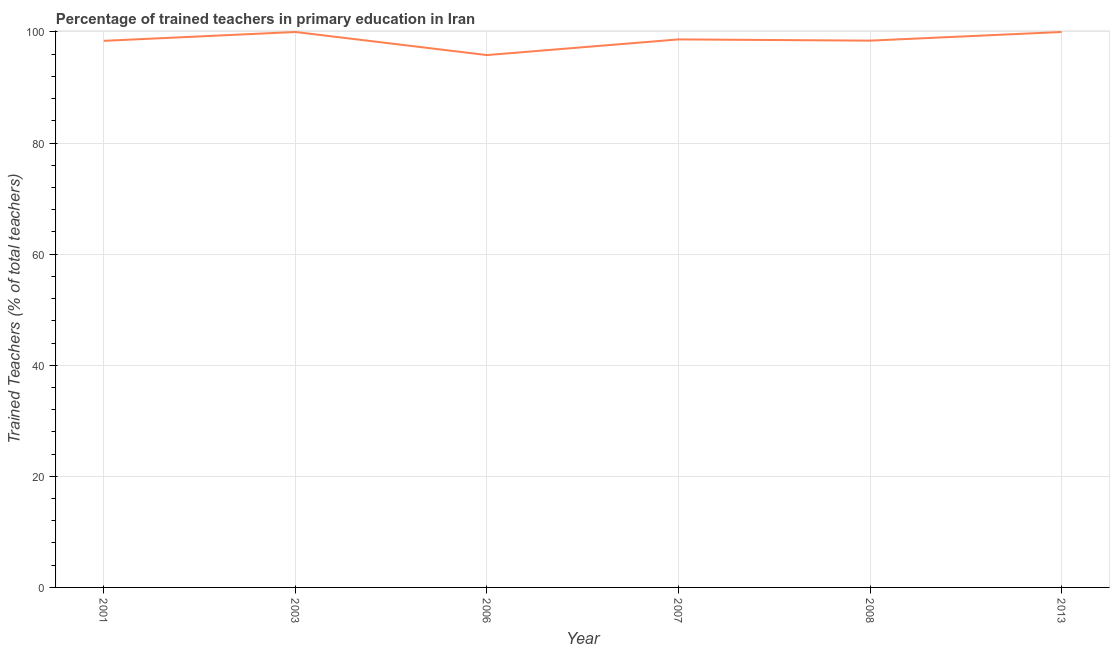What is the percentage of trained teachers in 2006?
Give a very brief answer. 95.84. Across all years, what is the maximum percentage of trained teachers?
Your response must be concise. 100. Across all years, what is the minimum percentage of trained teachers?
Your response must be concise. 95.84. In which year was the percentage of trained teachers maximum?
Offer a very short reply. 2003. What is the sum of the percentage of trained teachers?
Your answer should be compact. 591.35. What is the difference between the percentage of trained teachers in 2007 and 2013?
Make the answer very short. -1.34. What is the average percentage of trained teachers per year?
Ensure brevity in your answer.  98.56. What is the median percentage of trained teachers?
Keep it short and to the point. 98.55. Do a majority of the years between 2001 and 2006 (inclusive) have percentage of trained teachers greater than 48 %?
Give a very brief answer. Yes. What is the ratio of the percentage of trained teachers in 2006 to that in 2007?
Give a very brief answer. 0.97. Is the percentage of trained teachers in 2006 less than that in 2008?
Give a very brief answer. Yes. Is the sum of the percentage of trained teachers in 2001 and 2008 greater than the maximum percentage of trained teachers across all years?
Give a very brief answer. Yes. What is the difference between the highest and the lowest percentage of trained teachers?
Offer a terse response. 4.16. In how many years, is the percentage of trained teachers greater than the average percentage of trained teachers taken over all years?
Give a very brief answer. 3. What is the difference between two consecutive major ticks on the Y-axis?
Give a very brief answer. 20. Are the values on the major ticks of Y-axis written in scientific E-notation?
Offer a terse response. No. Does the graph contain any zero values?
Your answer should be compact. No. Does the graph contain grids?
Make the answer very short. Yes. What is the title of the graph?
Give a very brief answer. Percentage of trained teachers in primary education in Iran. What is the label or title of the Y-axis?
Make the answer very short. Trained Teachers (% of total teachers). What is the Trained Teachers (% of total teachers) of 2001?
Offer a terse response. 98.4. What is the Trained Teachers (% of total teachers) in 2003?
Make the answer very short. 100. What is the Trained Teachers (% of total teachers) in 2006?
Your answer should be compact. 95.84. What is the Trained Teachers (% of total teachers) in 2007?
Provide a short and direct response. 98.66. What is the Trained Teachers (% of total teachers) of 2008?
Provide a short and direct response. 98.44. What is the difference between the Trained Teachers (% of total teachers) in 2001 and 2003?
Your answer should be compact. -1.6. What is the difference between the Trained Teachers (% of total teachers) in 2001 and 2006?
Keep it short and to the point. 2.56. What is the difference between the Trained Teachers (% of total teachers) in 2001 and 2007?
Offer a terse response. -0.26. What is the difference between the Trained Teachers (% of total teachers) in 2001 and 2008?
Provide a short and direct response. -0.04. What is the difference between the Trained Teachers (% of total teachers) in 2001 and 2013?
Offer a terse response. -1.6. What is the difference between the Trained Teachers (% of total teachers) in 2003 and 2006?
Your answer should be very brief. 4.16. What is the difference between the Trained Teachers (% of total teachers) in 2003 and 2007?
Your answer should be compact. 1.34. What is the difference between the Trained Teachers (% of total teachers) in 2003 and 2008?
Make the answer very short. 1.56. What is the difference between the Trained Teachers (% of total teachers) in 2006 and 2007?
Offer a very short reply. -2.82. What is the difference between the Trained Teachers (% of total teachers) in 2006 and 2008?
Your answer should be very brief. -2.6. What is the difference between the Trained Teachers (% of total teachers) in 2006 and 2013?
Your response must be concise. -4.16. What is the difference between the Trained Teachers (% of total teachers) in 2007 and 2008?
Provide a succinct answer. 0.22. What is the difference between the Trained Teachers (% of total teachers) in 2007 and 2013?
Ensure brevity in your answer.  -1.34. What is the difference between the Trained Teachers (% of total teachers) in 2008 and 2013?
Offer a terse response. -1.56. What is the ratio of the Trained Teachers (% of total teachers) in 2001 to that in 2006?
Make the answer very short. 1.03. What is the ratio of the Trained Teachers (% of total teachers) in 2003 to that in 2006?
Offer a terse response. 1.04. What is the ratio of the Trained Teachers (% of total teachers) in 2003 to that in 2007?
Keep it short and to the point. 1.01. What is the ratio of the Trained Teachers (% of total teachers) in 2006 to that in 2013?
Provide a short and direct response. 0.96. What is the ratio of the Trained Teachers (% of total teachers) in 2007 to that in 2008?
Make the answer very short. 1. What is the ratio of the Trained Teachers (% of total teachers) in 2007 to that in 2013?
Offer a terse response. 0.99. What is the ratio of the Trained Teachers (% of total teachers) in 2008 to that in 2013?
Offer a terse response. 0.98. 